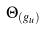<formula> <loc_0><loc_0><loc_500><loc_500>\Theta _ { ( g _ { u } ) }</formula> 